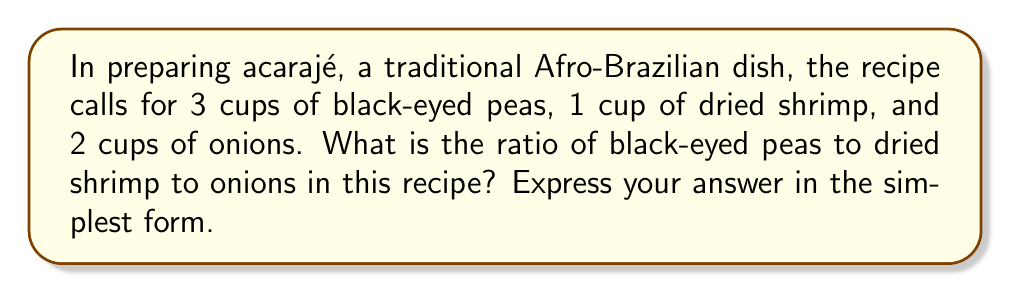What is the answer to this math problem? To find the ratio of black-eyed peas to dried shrimp to onions, we need to compare the quantities of each ingredient:

1. Black-eyed peas: 3 cups
2. Dried shrimp: 1 cup
3. Onions: 2 cups

The ratio is written in the order given in the question: black-eyed peas : dried shrimp : onions

So, we start with: 3 : 1 : 2

To simplify this ratio, we need to find the greatest common divisor (GCD) of these numbers:

$GCD(3, 1, 2) = 1$

Since the GCD is 1, this ratio is already in its simplest form.

Therefore, the simplified ratio of black-eyed peas to dried shrimp to onions is 3 : 1 : 2.

We can verify this by dividing each number by the GCD:

$$\frac{3}{1} : \frac{1}{1} : \frac{2}{1} = 3 : 1 : 2$$

This ratio means that for every 3 parts of black-eyed peas, there is 1 part of dried shrimp and 2 parts of onions in the acarajé recipe.
Answer: 3 : 1 : 2 